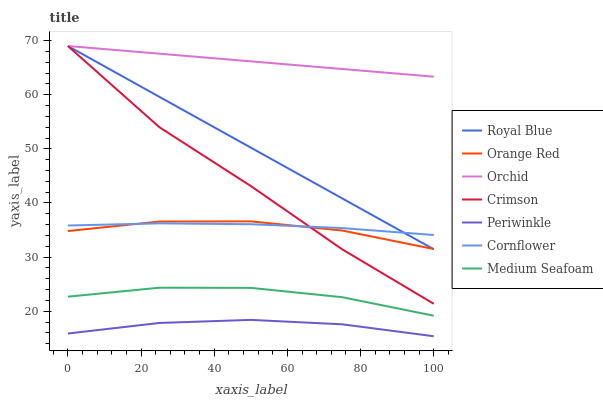Does Periwinkle have the minimum area under the curve?
Answer yes or no. Yes. Does Orchid have the maximum area under the curve?
Answer yes or no. Yes. Does Medium Seafoam have the minimum area under the curve?
Answer yes or no. No. Does Medium Seafoam have the maximum area under the curve?
Answer yes or no. No. Is Royal Blue the smoothest?
Answer yes or no. Yes. Is Crimson the roughest?
Answer yes or no. Yes. Is Medium Seafoam the smoothest?
Answer yes or no. No. Is Medium Seafoam the roughest?
Answer yes or no. No. Does Periwinkle have the lowest value?
Answer yes or no. Yes. Does Medium Seafoam have the lowest value?
Answer yes or no. No. Does Orchid have the highest value?
Answer yes or no. Yes. Does Medium Seafoam have the highest value?
Answer yes or no. No. Is Orange Red less than Orchid?
Answer yes or no. Yes. Is Crimson greater than Periwinkle?
Answer yes or no. Yes. Does Cornflower intersect Crimson?
Answer yes or no. Yes. Is Cornflower less than Crimson?
Answer yes or no. No. Is Cornflower greater than Crimson?
Answer yes or no. No. Does Orange Red intersect Orchid?
Answer yes or no. No. 